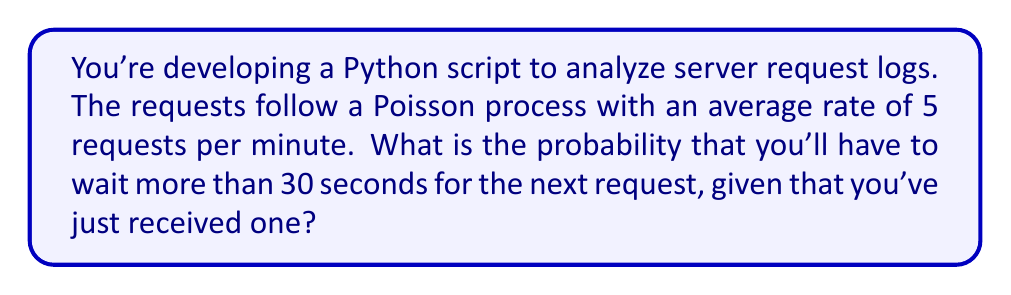Could you help me with this problem? Let's approach this step-by-step:

1) In a Poisson process, the waiting times between events follow an exponential distribution.

2) The rate parameter λ for the exponential distribution is the same as the rate of the Poisson process. Here, λ = 5 requests/minute.

3) We need to convert this to requests/second:
   λ = 5/60 ≈ 0.0833 requests/second

4) The cumulative distribution function (CDF) of an exponential distribution is:

   $F(t) = 1 - e^{-λt}$

5) We want the probability of waiting more than 30 seconds, which is the complement of waiting 30 seconds or less:

   $P(T > 30) = 1 - P(T ≤ 30) = 1 - F(30)$

6) Substituting into the CDF formula:

   $P(T > 30) = 1 - (1 - e^{-λ * 30})$
               $= e^{-λ * 30}$
               $= e^{-0.0833 * 30}$
               $= e^{-2.5}$

7) Calculating this value:

   $e^{-2.5} ≈ 0.0821$

Therefore, the probability of waiting more than 30 seconds for the next request is approximately 0.0821 or 8.21%.
Answer: $0.0821$ or $8.21\%$ 